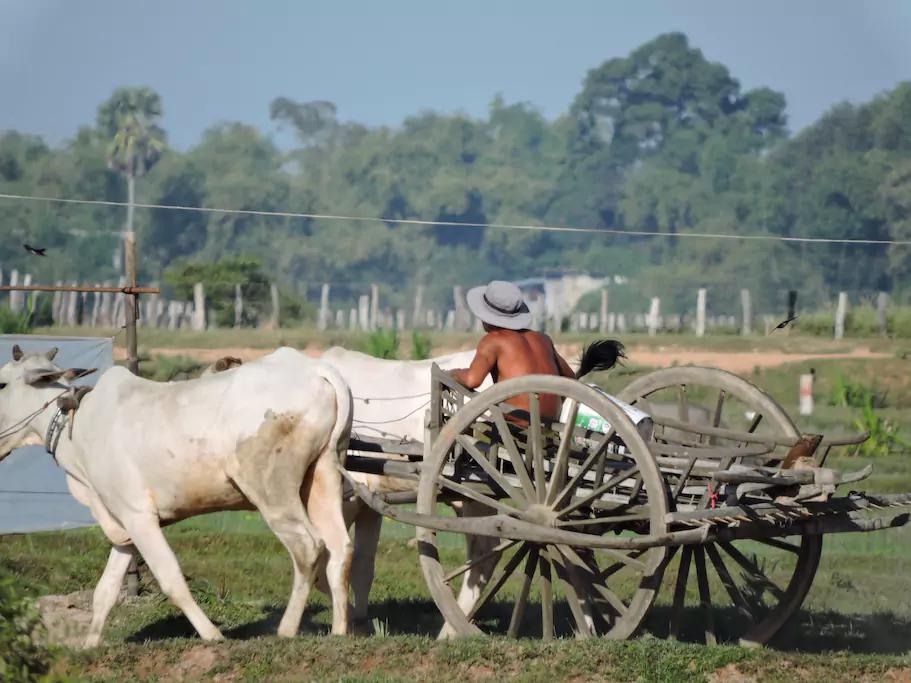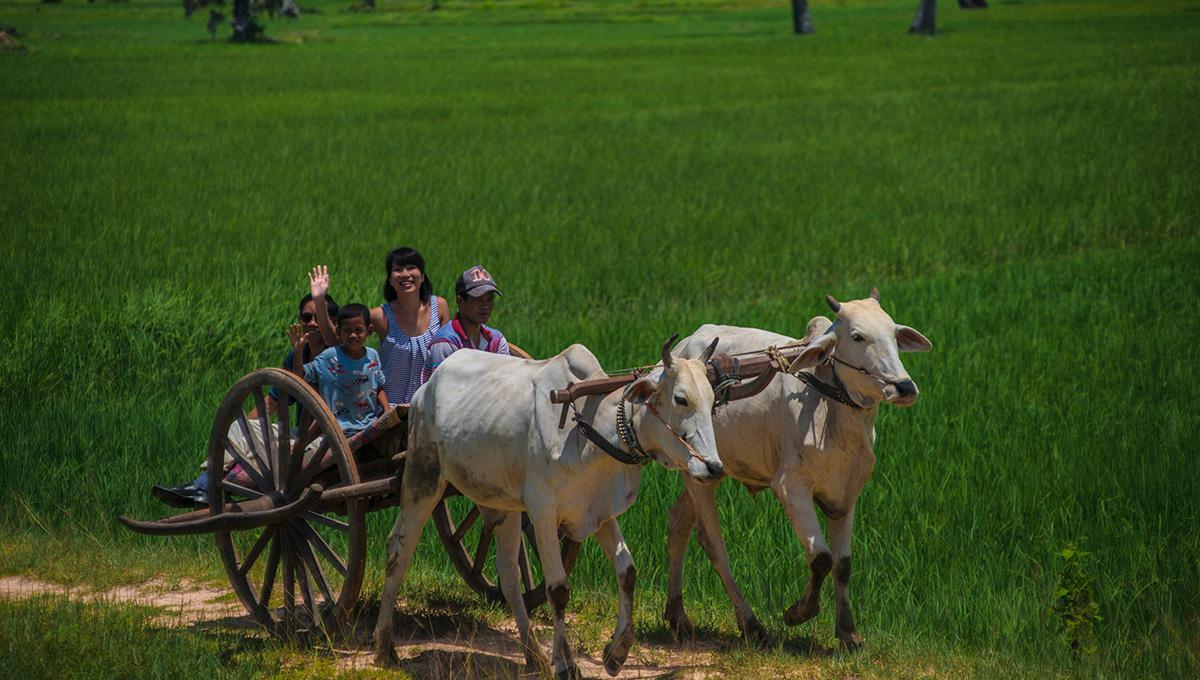The first image is the image on the left, the second image is the image on the right. For the images displayed, is the sentence "In one image, two dark oxen pull a two-wheeled cart with two passengers and a driver in a cap leftward." factually correct? Answer yes or no. No. The first image is the image on the left, the second image is the image on the right. Given the left and right images, does the statement "there is only one person in one of the images." hold true? Answer yes or no. Yes. 